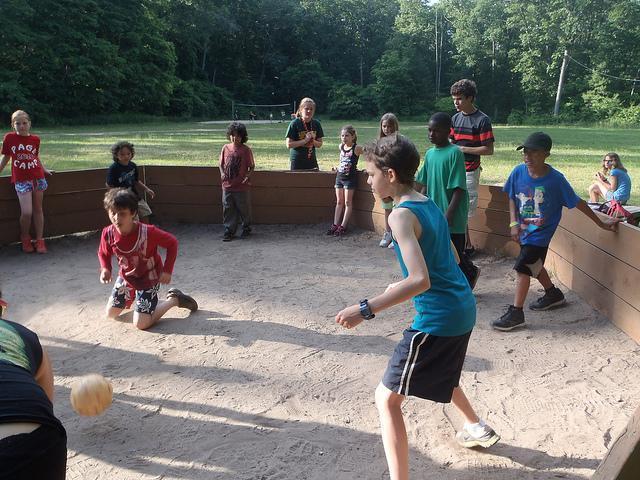How many women are sitting on the cement?
Give a very brief answer. 0. How many boys are pictured?
Give a very brief answer. 7. How many people are there?
Give a very brief answer. 8. 